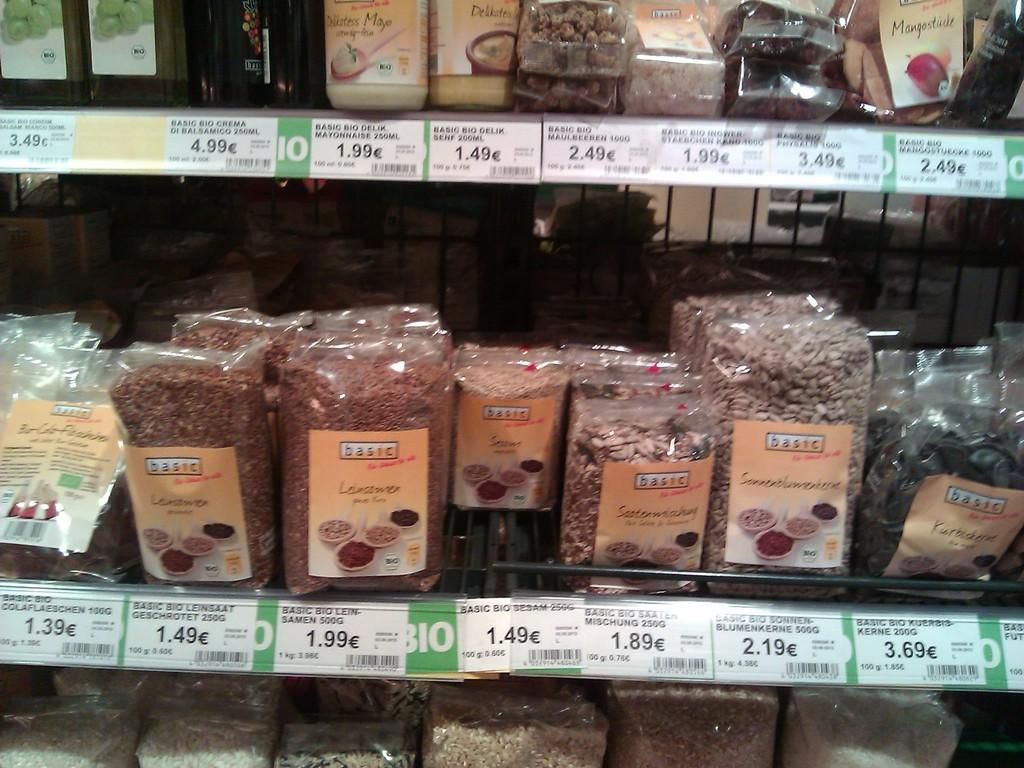Provide a one-sentence caption for the provided image. a grocery store isle with basic brand food. 